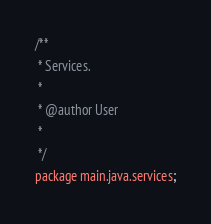Convert code to text. <code><loc_0><loc_0><loc_500><loc_500><_Java_>
/**
 * Services.
 * 
 * @author User
 *
 */
package main.java.services;</code> 